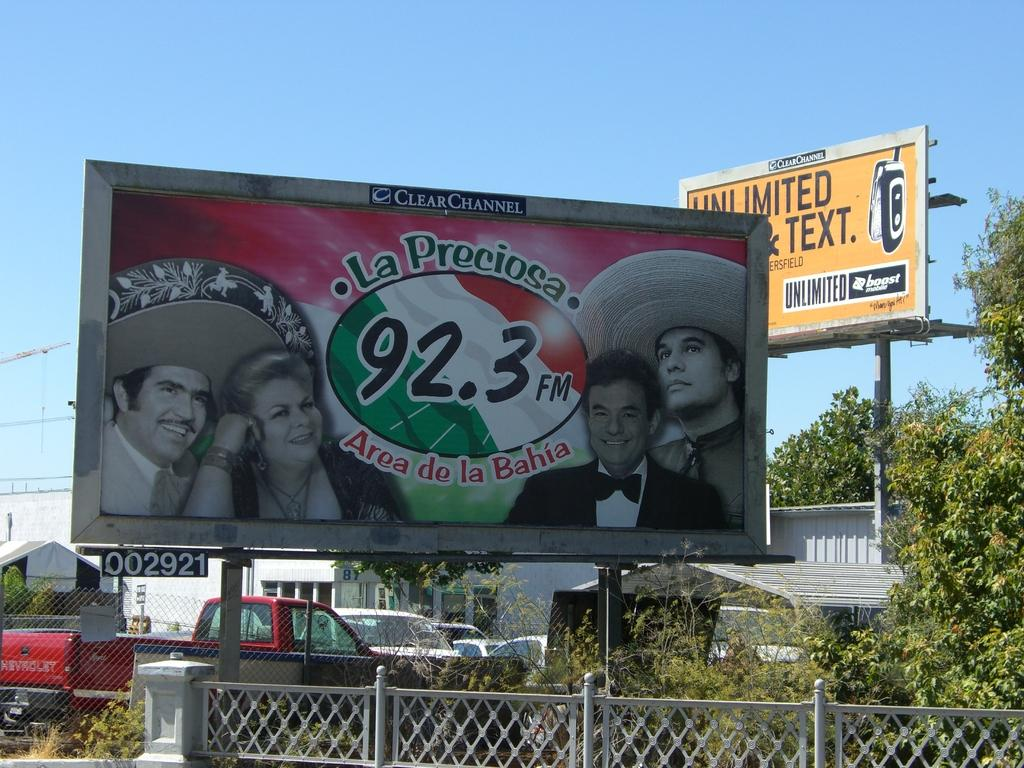<image>
Provide a brief description of the given image. ClearChannel has a station called 92.3FM - La Preciosa. 